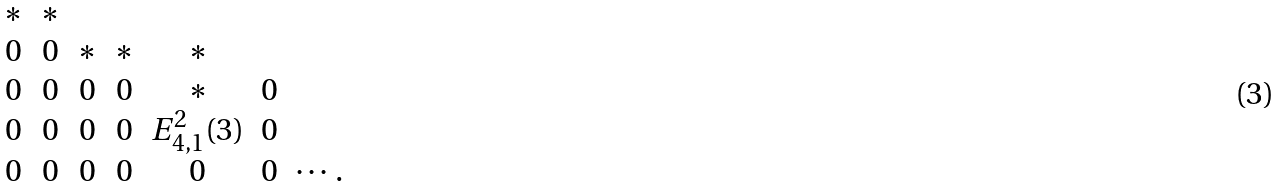<formula> <loc_0><loc_0><loc_500><loc_500>\begin{array} { c c c c c c c } \ast & \ast & & & & & \\ 0 & 0 & \ast & \ast & \ast & & \\ 0 & 0 & 0 & 0 & \ast & 0 & \\ 0 & 0 & 0 & 0 & E _ { 4 , 1 } ^ { 2 } ( 3 ) & 0 & \\ 0 & 0 & 0 & 0 & 0 & 0 & \cdots . \end{array}</formula> 